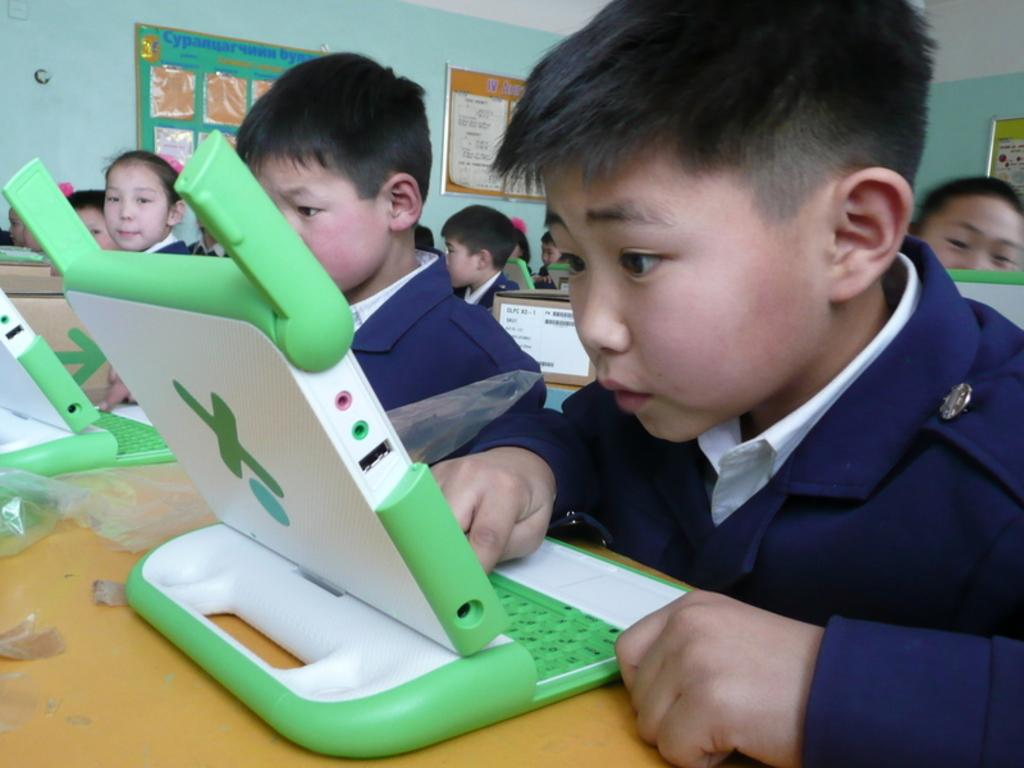What is the main piece of furniture in the image? There is a table in the image. What electronic device is on the table? A laptop is present on the table. Who is in front of the table? There are children in front of the table. What is on the wall in the image? Notice papers are attached to the wall. Can you see a person holding a clam in the image? There is no person holding a clam in the image. Is there a cannon visible on the table? There is no cannon present in the image. 